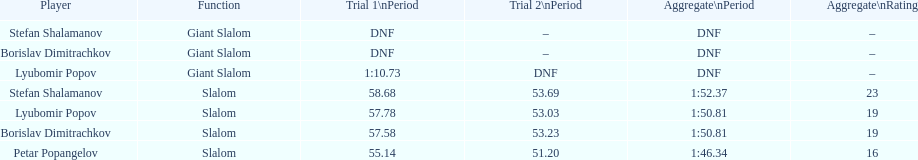Could you parse the entire table as a dict? {'header': ['Player', 'Function', 'Trial 1\\nPeriod', 'Trial 2\\nPeriod', 'Aggregate\\nPeriod', 'Aggregate\\nRating'], 'rows': [['Stefan Shalamanov', 'Giant Slalom', 'DNF', '–', 'DNF', '–'], ['Borislav Dimitrachkov', 'Giant Slalom', 'DNF', '–', 'DNF', '–'], ['Lyubomir Popov', 'Giant Slalom', '1:10.73', 'DNF', 'DNF', '–'], ['Stefan Shalamanov', 'Slalom', '58.68', '53.69', '1:52.37', '23'], ['Lyubomir Popov', 'Slalom', '57.78', '53.03', '1:50.81', '19'], ['Borislav Dimitrachkov', 'Slalom', '57.58', '53.23', '1:50.81', '19'], ['Petar Popangelov', 'Slalom', '55.14', '51.20', '1:46.34', '16']]} Who came after borislav dimitrachkov and it's time for slalom Petar Popangelov. 